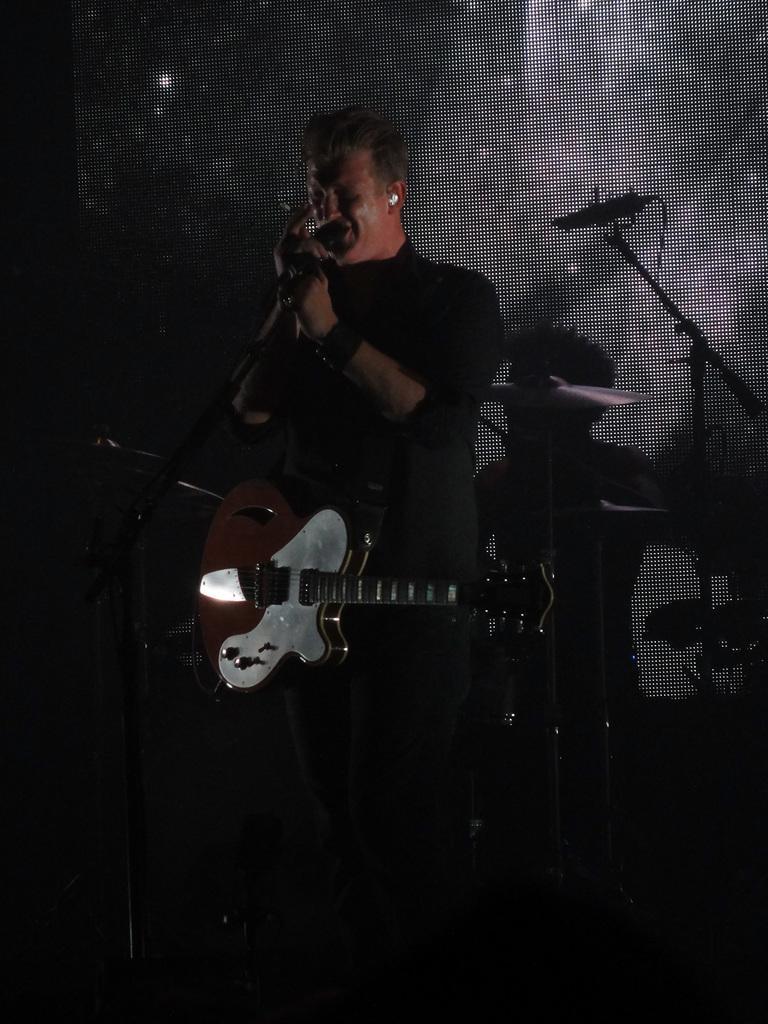In one or two sentences, can you explain what this image depicts? In the picture there is man standing and singing holding the microphone. He is also wearing a guitar on him. He is dressed in black. Behind him there is screen or wall on which the shadow of him and microphone can be seen. There is also microphone stand on which the microphone is placed. Behind him there are some drums. 